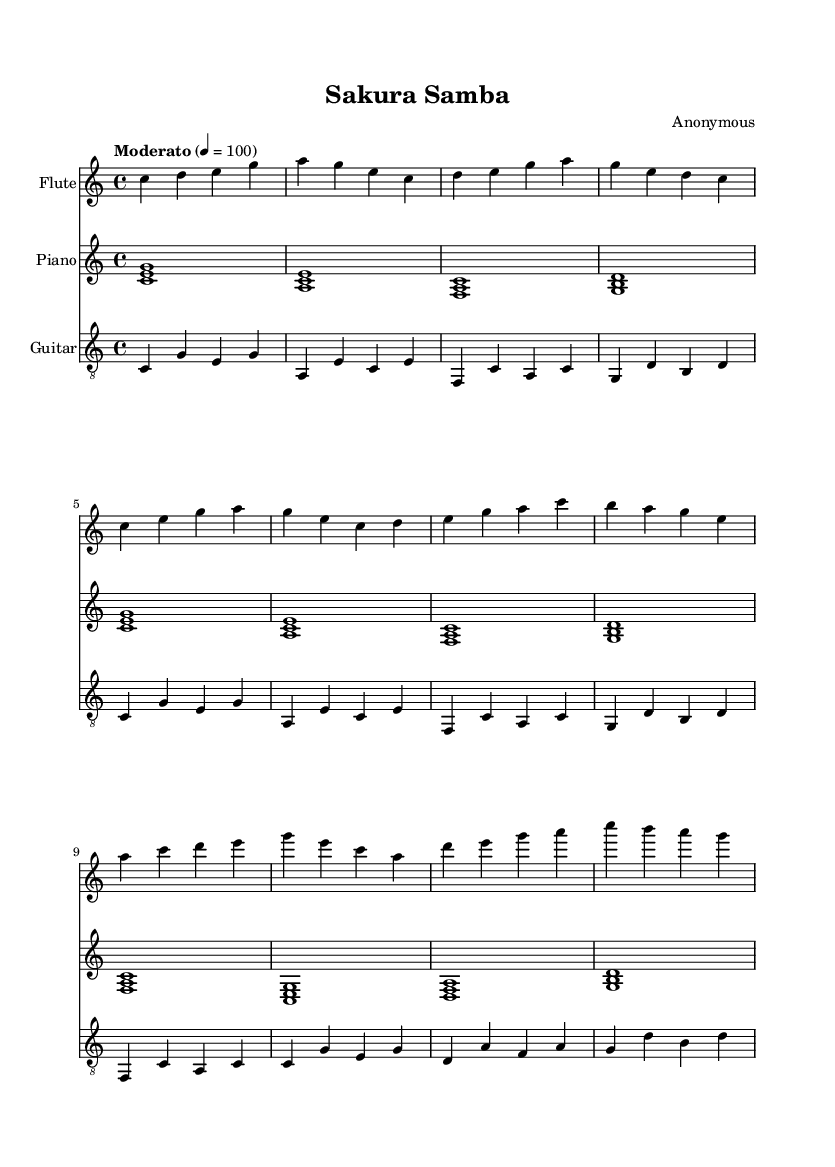What is the key signature of this music? The key signature indicates the key of C major, which has no sharps or flats.
Answer: C major What is the time signature of this music? The time signature shown at the beginning is 4/4, indicating that there are four beats in a measure and a quarter note gets one beat.
Answer: 4/4 What is the tempo marking used in this piece? The tempo marking indicates "Moderato," which suggests a moderate speed for the performance, usually around 100 beats per minute.
Answer: Moderato How many measures are in the intro section? Counting the measures in the intro section carefully, there are 4 measures presented before the verse begins.
Answer: 4 What instrument is featured in the first part of the music? The flute part is presented first in the score, indicating its importance as the lead instrument in this piece.
Answer: Flute Which chords are played during the chorus? In the chorus, the chords are F, C, D, and G noted in the piano part, showing the harmonic structure for this section.
Answer: F, C, D, G What unique characteristic does this piece have related to its influence? The presence of Japanese musical influences, particularly in the melodic structure and rhythm, reflects the diplomatic relations explored through music.
Answer: Japanese influences 